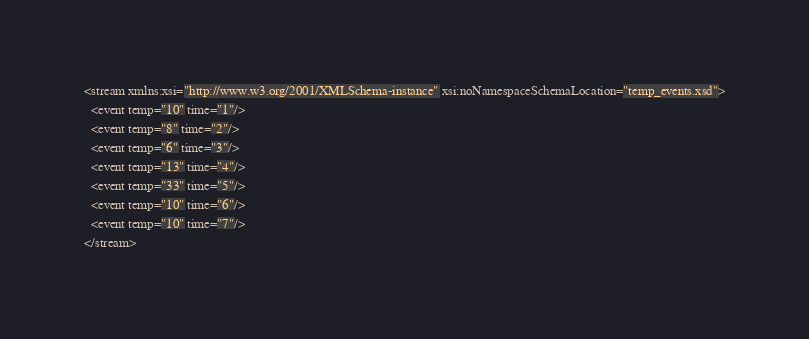Convert code to text. <code><loc_0><loc_0><loc_500><loc_500><_XML_><stream xmlns:xsi="http://www.w3.org/2001/XMLSchema-instance" xsi:noNamespaceSchemaLocation="temp_events.xsd">
  <event temp="10" time="1"/>
  <event temp="8" time="2"/>
  <event temp="6" time="3"/>
  <event temp="13" time="4"/>
  <event temp="33" time="5"/>
  <event temp="10" time="6"/>
  <event temp="10" time="7"/>
</stream>
</code> 